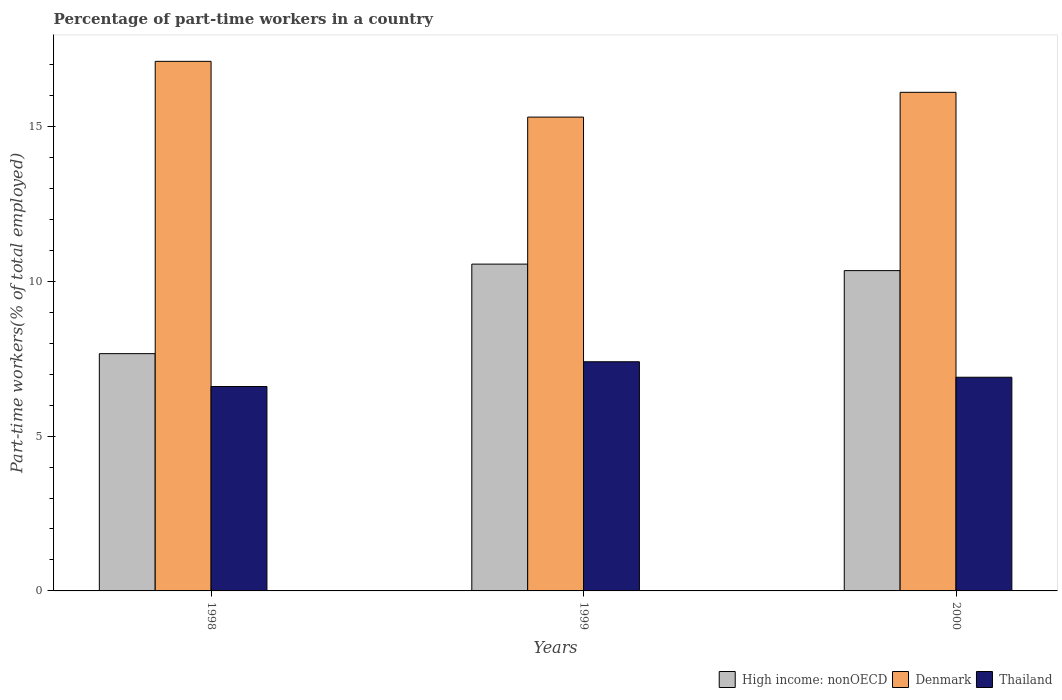How many different coloured bars are there?
Offer a terse response. 3. How many groups of bars are there?
Offer a very short reply. 3. Are the number of bars per tick equal to the number of legend labels?
Your response must be concise. Yes. How many bars are there on the 1st tick from the left?
Offer a terse response. 3. How many bars are there on the 3rd tick from the right?
Make the answer very short. 3. In how many cases, is the number of bars for a given year not equal to the number of legend labels?
Provide a short and direct response. 0. What is the percentage of part-time workers in High income: nonOECD in 2000?
Provide a succinct answer. 10.34. Across all years, what is the maximum percentage of part-time workers in Denmark?
Keep it short and to the point. 17.1. Across all years, what is the minimum percentage of part-time workers in Denmark?
Your answer should be very brief. 15.3. What is the total percentage of part-time workers in Denmark in the graph?
Your answer should be compact. 48.5. What is the difference between the percentage of part-time workers in High income: nonOECD in 1998 and that in 1999?
Give a very brief answer. -2.89. What is the difference between the percentage of part-time workers in High income: nonOECD in 2000 and the percentage of part-time workers in Thailand in 1998?
Ensure brevity in your answer.  3.74. What is the average percentage of part-time workers in Denmark per year?
Your answer should be compact. 16.17. In the year 1998, what is the difference between the percentage of part-time workers in High income: nonOECD and percentage of part-time workers in Thailand?
Give a very brief answer. 1.06. What is the ratio of the percentage of part-time workers in Thailand in 1999 to that in 2000?
Your answer should be very brief. 1.07. Is the percentage of part-time workers in High income: nonOECD in 1999 less than that in 2000?
Provide a short and direct response. No. What is the difference between the highest and the second highest percentage of part-time workers in Thailand?
Offer a very short reply. 0.5. What is the difference between the highest and the lowest percentage of part-time workers in High income: nonOECD?
Your answer should be compact. 2.89. Is the sum of the percentage of part-time workers in High income: nonOECD in 1998 and 1999 greater than the maximum percentage of part-time workers in Thailand across all years?
Your response must be concise. Yes. What does the 1st bar from the left in 2000 represents?
Your answer should be very brief. High income: nonOECD. What does the 1st bar from the right in 2000 represents?
Your answer should be compact. Thailand. Are all the bars in the graph horizontal?
Provide a succinct answer. No. What is the difference between two consecutive major ticks on the Y-axis?
Offer a very short reply. 5. Does the graph contain any zero values?
Your answer should be very brief. No. Does the graph contain grids?
Offer a very short reply. No. Where does the legend appear in the graph?
Offer a very short reply. Bottom right. How are the legend labels stacked?
Keep it short and to the point. Horizontal. What is the title of the graph?
Provide a short and direct response. Percentage of part-time workers in a country. Does "Haiti" appear as one of the legend labels in the graph?
Your answer should be compact. No. What is the label or title of the Y-axis?
Keep it short and to the point. Part-time workers(% of total employed). What is the Part-time workers(% of total employed) of High income: nonOECD in 1998?
Your response must be concise. 7.66. What is the Part-time workers(% of total employed) of Denmark in 1998?
Your answer should be compact. 17.1. What is the Part-time workers(% of total employed) in Thailand in 1998?
Provide a short and direct response. 6.6. What is the Part-time workers(% of total employed) in High income: nonOECD in 1999?
Keep it short and to the point. 10.55. What is the Part-time workers(% of total employed) of Denmark in 1999?
Keep it short and to the point. 15.3. What is the Part-time workers(% of total employed) in Thailand in 1999?
Give a very brief answer. 7.4. What is the Part-time workers(% of total employed) in High income: nonOECD in 2000?
Give a very brief answer. 10.34. What is the Part-time workers(% of total employed) in Denmark in 2000?
Ensure brevity in your answer.  16.1. What is the Part-time workers(% of total employed) in Thailand in 2000?
Your answer should be compact. 6.9. Across all years, what is the maximum Part-time workers(% of total employed) in High income: nonOECD?
Offer a very short reply. 10.55. Across all years, what is the maximum Part-time workers(% of total employed) in Denmark?
Provide a succinct answer. 17.1. Across all years, what is the maximum Part-time workers(% of total employed) in Thailand?
Make the answer very short. 7.4. Across all years, what is the minimum Part-time workers(% of total employed) of High income: nonOECD?
Provide a succinct answer. 7.66. Across all years, what is the minimum Part-time workers(% of total employed) of Denmark?
Provide a short and direct response. 15.3. Across all years, what is the minimum Part-time workers(% of total employed) of Thailand?
Give a very brief answer. 6.6. What is the total Part-time workers(% of total employed) in High income: nonOECD in the graph?
Keep it short and to the point. 28.56. What is the total Part-time workers(% of total employed) in Denmark in the graph?
Provide a short and direct response. 48.5. What is the total Part-time workers(% of total employed) of Thailand in the graph?
Your answer should be compact. 20.9. What is the difference between the Part-time workers(% of total employed) of High income: nonOECD in 1998 and that in 1999?
Your response must be concise. -2.89. What is the difference between the Part-time workers(% of total employed) in Denmark in 1998 and that in 1999?
Offer a very short reply. 1.8. What is the difference between the Part-time workers(% of total employed) of Thailand in 1998 and that in 1999?
Your answer should be very brief. -0.8. What is the difference between the Part-time workers(% of total employed) of High income: nonOECD in 1998 and that in 2000?
Ensure brevity in your answer.  -2.68. What is the difference between the Part-time workers(% of total employed) of High income: nonOECD in 1999 and that in 2000?
Your response must be concise. 0.21. What is the difference between the Part-time workers(% of total employed) of Denmark in 1999 and that in 2000?
Offer a terse response. -0.8. What is the difference between the Part-time workers(% of total employed) in High income: nonOECD in 1998 and the Part-time workers(% of total employed) in Denmark in 1999?
Provide a succinct answer. -7.64. What is the difference between the Part-time workers(% of total employed) of High income: nonOECD in 1998 and the Part-time workers(% of total employed) of Thailand in 1999?
Make the answer very short. 0.26. What is the difference between the Part-time workers(% of total employed) of Denmark in 1998 and the Part-time workers(% of total employed) of Thailand in 1999?
Your response must be concise. 9.7. What is the difference between the Part-time workers(% of total employed) of High income: nonOECD in 1998 and the Part-time workers(% of total employed) of Denmark in 2000?
Provide a succinct answer. -8.44. What is the difference between the Part-time workers(% of total employed) in High income: nonOECD in 1998 and the Part-time workers(% of total employed) in Thailand in 2000?
Offer a very short reply. 0.76. What is the difference between the Part-time workers(% of total employed) of High income: nonOECD in 1999 and the Part-time workers(% of total employed) of Denmark in 2000?
Ensure brevity in your answer.  -5.55. What is the difference between the Part-time workers(% of total employed) in High income: nonOECD in 1999 and the Part-time workers(% of total employed) in Thailand in 2000?
Ensure brevity in your answer.  3.65. What is the difference between the Part-time workers(% of total employed) in Denmark in 1999 and the Part-time workers(% of total employed) in Thailand in 2000?
Give a very brief answer. 8.4. What is the average Part-time workers(% of total employed) in High income: nonOECD per year?
Provide a succinct answer. 9.52. What is the average Part-time workers(% of total employed) of Denmark per year?
Ensure brevity in your answer.  16.17. What is the average Part-time workers(% of total employed) in Thailand per year?
Offer a terse response. 6.97. In the year 1998, what is the difference between the Part-time workers(% of total employed) in High income: nonOECD and Part-time workers(% of total employed) in Denmark?
Provide a short and direct response. -9.44. In the year 1998, what is the difference between the Part-time workers(% of total employed) of High income: nonOECD and Part-time workers(% of total employed) of Thailand?
Your answer should be very brief. 1.06. In the year 1998, what is the difference between the Part-time workers(% of total employed) of Denmark and Part-time workers(% of total employed) of Thailand?
Your answer should be compact. 10.5. In the year 1999, what is the difference between the Part-time workers(% of total employed) in High income: nonOECD and Part-time workers(% of total employed) in Denmark?
Offer a terse response. -4.75. In the year 1999, what is the difference between the Part-time workers(% of total employed) in High income: nonOECD and Part-time workers(% of total employed) in Thailand?
Your response must be concise. 3.15. In the year 1999, what is the difference between the Part-time workers(% of total employed) in Denmark and Part-time workers(% of total employed) in Thailand?
Make the answer very short. 7.9. In the year 2000, what is the difference between the Part-time workers(% of total employed) in High income: nonOECD and Part-time workers(% of total employed) in Denmark?
Give a very brief answer. -5.76. In the year 2000, what is the difference between the Part-time workers(% of total employed) in High income: nonOECD and Part-time workers(% of total employed) in Thailand?
Keep it short and to the point. 3.44. In the year 2000, what is the difference between the Part-time workers(% of total employed) of Denmark and Part-time workers(% of total employed) of Thailand?
Your answer should be very brief. 9.2. What is the ratio of the Part-time workers(% of total employed) of High income: nonOECD in 1998 to that in 1999?
Your answer should be compact. 0.73. What is the ratio of the Part-time workers(% of total employed) in Denmark in 1998 to that in 1999?
Offer a terse response. 1.12. What is the ratio of the Part-time workers(% of total employed) of Thailand in 1998 to that in 1999?
Ensure brevity in your answer.  0.89. What is the ratio of the Part-time workers(% of total employed) in High income: nonOECD in 1998 to that in 2000?
Give a very brief answer. 0.74. What is the ratio of the Part-time workers(% of total employed) in Denmark in 1998 to that in 2000?
Keep it short and to the point. 1.06. What is the ratio of the Part-time workers(% of total employed) in Thailand in 1998 to that in 2000?
Ensure brevity in your answer.  0.96. What is the ratio of the Part-time workers(% of total employed) of High income: nonOECD in 1999 to that in 2000?
Make the answer very short. 1.02. What is the ratio of the Part-time workers(% of total employed) of Denmark in 1999 to that in 2000?
Keep it short and to the point. 0.95. What is the ratio of the Part-time workers(% of total employed) in Thailand in 1999 to that in 2000?
Ensure brevity in your answer.  1.07. What is the difference between the highest and the second highest Part-time workers(% of total employed) in High income: nonOECD?
Provide a succinct answer. 0.21. What is the difference between the highest and the second highest Part-time workers(% of total employed) in Denmark?
Provide a succinct answer. 1. What is the difference between the highest and the second highest Part-time workers(% of total employed) of Thailand?
Keep it short and to the point. 0.5. What is the difference between the highest and the lowest Part-time workers(% of total employed) of High income: nonOECD?
Offer a terse response. 2.89. What is the difference between the highest and the lowest Part-time workers(% of total employed) in Denmark?
Offer a very short reply. 1.8. What is the difference between the highest and the lowest Part-time workers(% of total employed) in Thailand?
Keep it short and to the point. 0.8. 